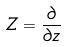<formula> <loc_0><loc_0><loc_500><loc_500>Z = \frac { \partial } { \partial z }</formula> 